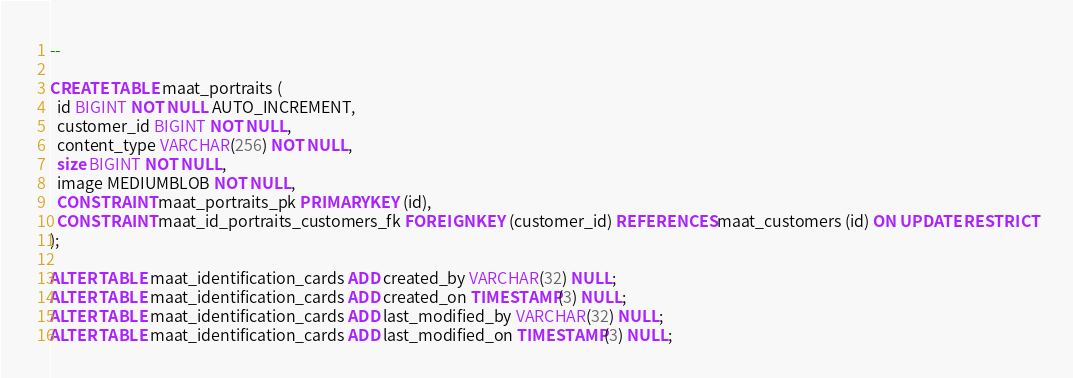Convert code to text. <code><loc_0><loc_0><loc_500><loc_500><_SQL_>--

CREATE TABLE maat_portraits (
  id BIGINT NOT NULL AUTO_INCREMENT,
  customer_id BIGINT NOT NULL,
  content_type VARCHAR(256) NOT NULL,
  size BIGINT NOT NULL,
  image MEDIUMBLOB NOT NULL,
  CONSTRAINT maat_portraits_pk PRIMARY KEY (id),
  CONSTRAINT maat_id_portraits_customers_fk FOREIGN KEY (customer_id) REFERENCES maat_customers (id) ON UPDATE RESTRICT
);

ALTER TABLE maat_identification_cards ADD created_by VARCHAR(32) NULL;
ALTER TABLE maat_identification_cards ADD created_on TIMESTAMP(3) NULL;
ALTER TABLE maat_identification_cards ADD last_modified_by VARCHAR(32) NULL;
ALTER TABLE maat_identification_cards ADD last_modified_on TIMESTAMP(3) NULL;
</code> 